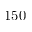Convert formula to latex. <formula><loc_0><loc_0><loc_500><loc_500>1 5 0</formula> 